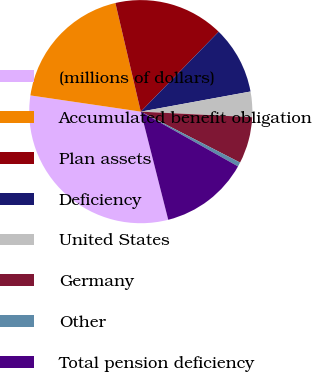Convert chart to OTSL. <chart><loc_0><loc_0><loc_500><loc_500><pie_chart><fcel>(millions of dollars)<fcel>Accumulated benefit obligation<fcel>Plan assets<fcel>Deficiency<fcel>United States<fcel>Germany<fcel>Other<fcel>Total pension deficiency<nl><fcel>31.28%<fcel>19.02%<fcel>15.95%<fcel>9.82%<fcel>3.68%<fcel>6.75%<fcel>0.62%<fcel>12.88%<nl></chart> 